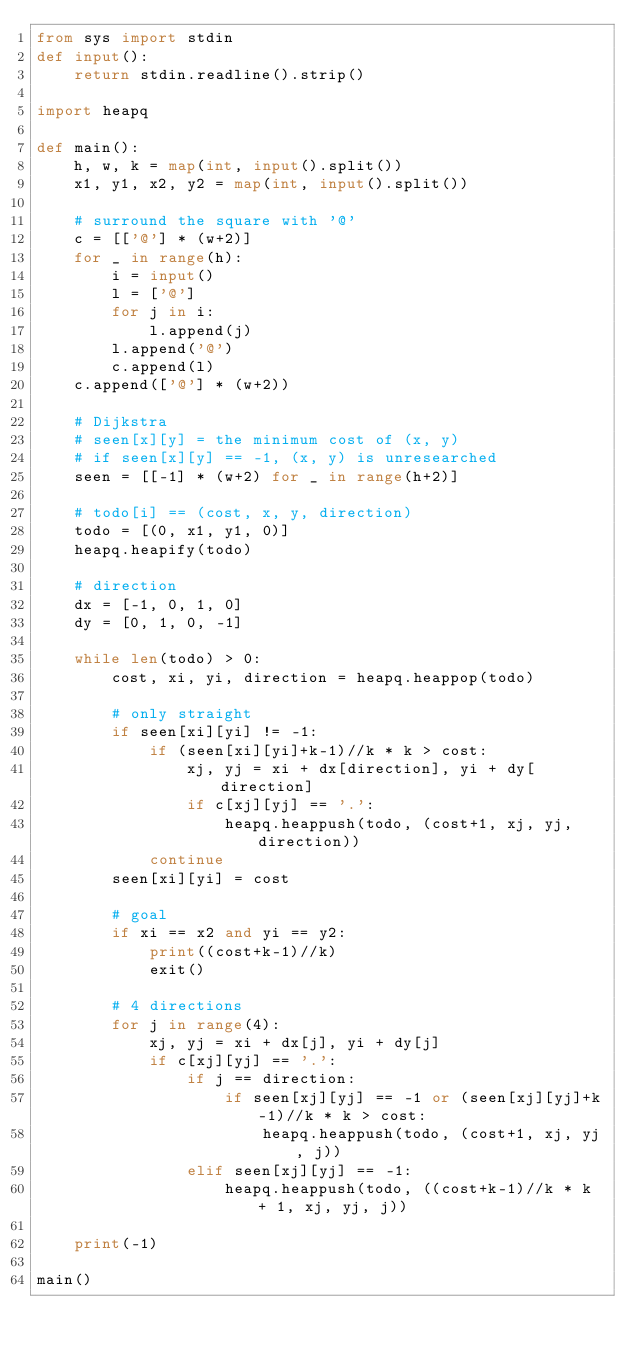<code> <loc_0><loc_0><loc_500><loc_500><_Python_>from sys import stdin
def input():
    return stdin.readline().strip()

import heapq

def main():
    h, w, k = map(int, input().split())
    x1, y1, x2, y2 = map(int, input().split())

    # surround the square with '@'
    c = [['@'] * (w+2)]
    for _ in range(h):
        i = input()
        l = ['@']
        for j in i:
            l.append(j)
        l.append('@')
        c.append(l)
    c.append(['@'] * (w+2))

    # Dijkstra
    # seen[x][y] = the minimum cost of (x, y)
    # if seen[x][y] == -1, (x, y) is unresearched
    seen = [[-1] * (w+2) for _ in range(h+2)]

    # todo[i] == (cost, x, y, direction)
    todo = [(0, x1, y1, 0)]
    heapq.heapify(todo)

    # direction
    dx = [-1, 0, 1, 0]
    dy = [0, 1, 0, -1]

    while len(todo) > 0:
        cost, xi, yi, direction = heapq.heappop(todo)

        # only straight
        if seen[xi][yi] != -1:
            if (seen[xi][yi]+k-1)//k * k > cost:
                xj, yj = xi + dx[direction], yi + dy[direction]
                if c[xj][yj] == '.':
                    heapq.heappush(todo, (cost+1, xj, yj, direction))
            continue
        seen[xi][yi] = cost

        # goal
        if xi == x2 and yi == y2:
            print((cost+k-1)//k)
            exit()
        
        # 4 directions
        for j in range(4):
            xj, yj = xi + dx[j], yi + dy[j]
            if c[xj][yj] == '.':
                if j == direction:
                    if seen[xj][yj] == -1 or (seen[xj][yj]+k-1)//k * k > cost:
                        heapq.heappush(todo, (cost+1, xj, yj, j))
                elif seen[xj][yj] == -1:
                    heapq.heappush(todo, ((cost+k-1)//k * k + 1, xj, yj, j))

    print(-1)

main()</code> 